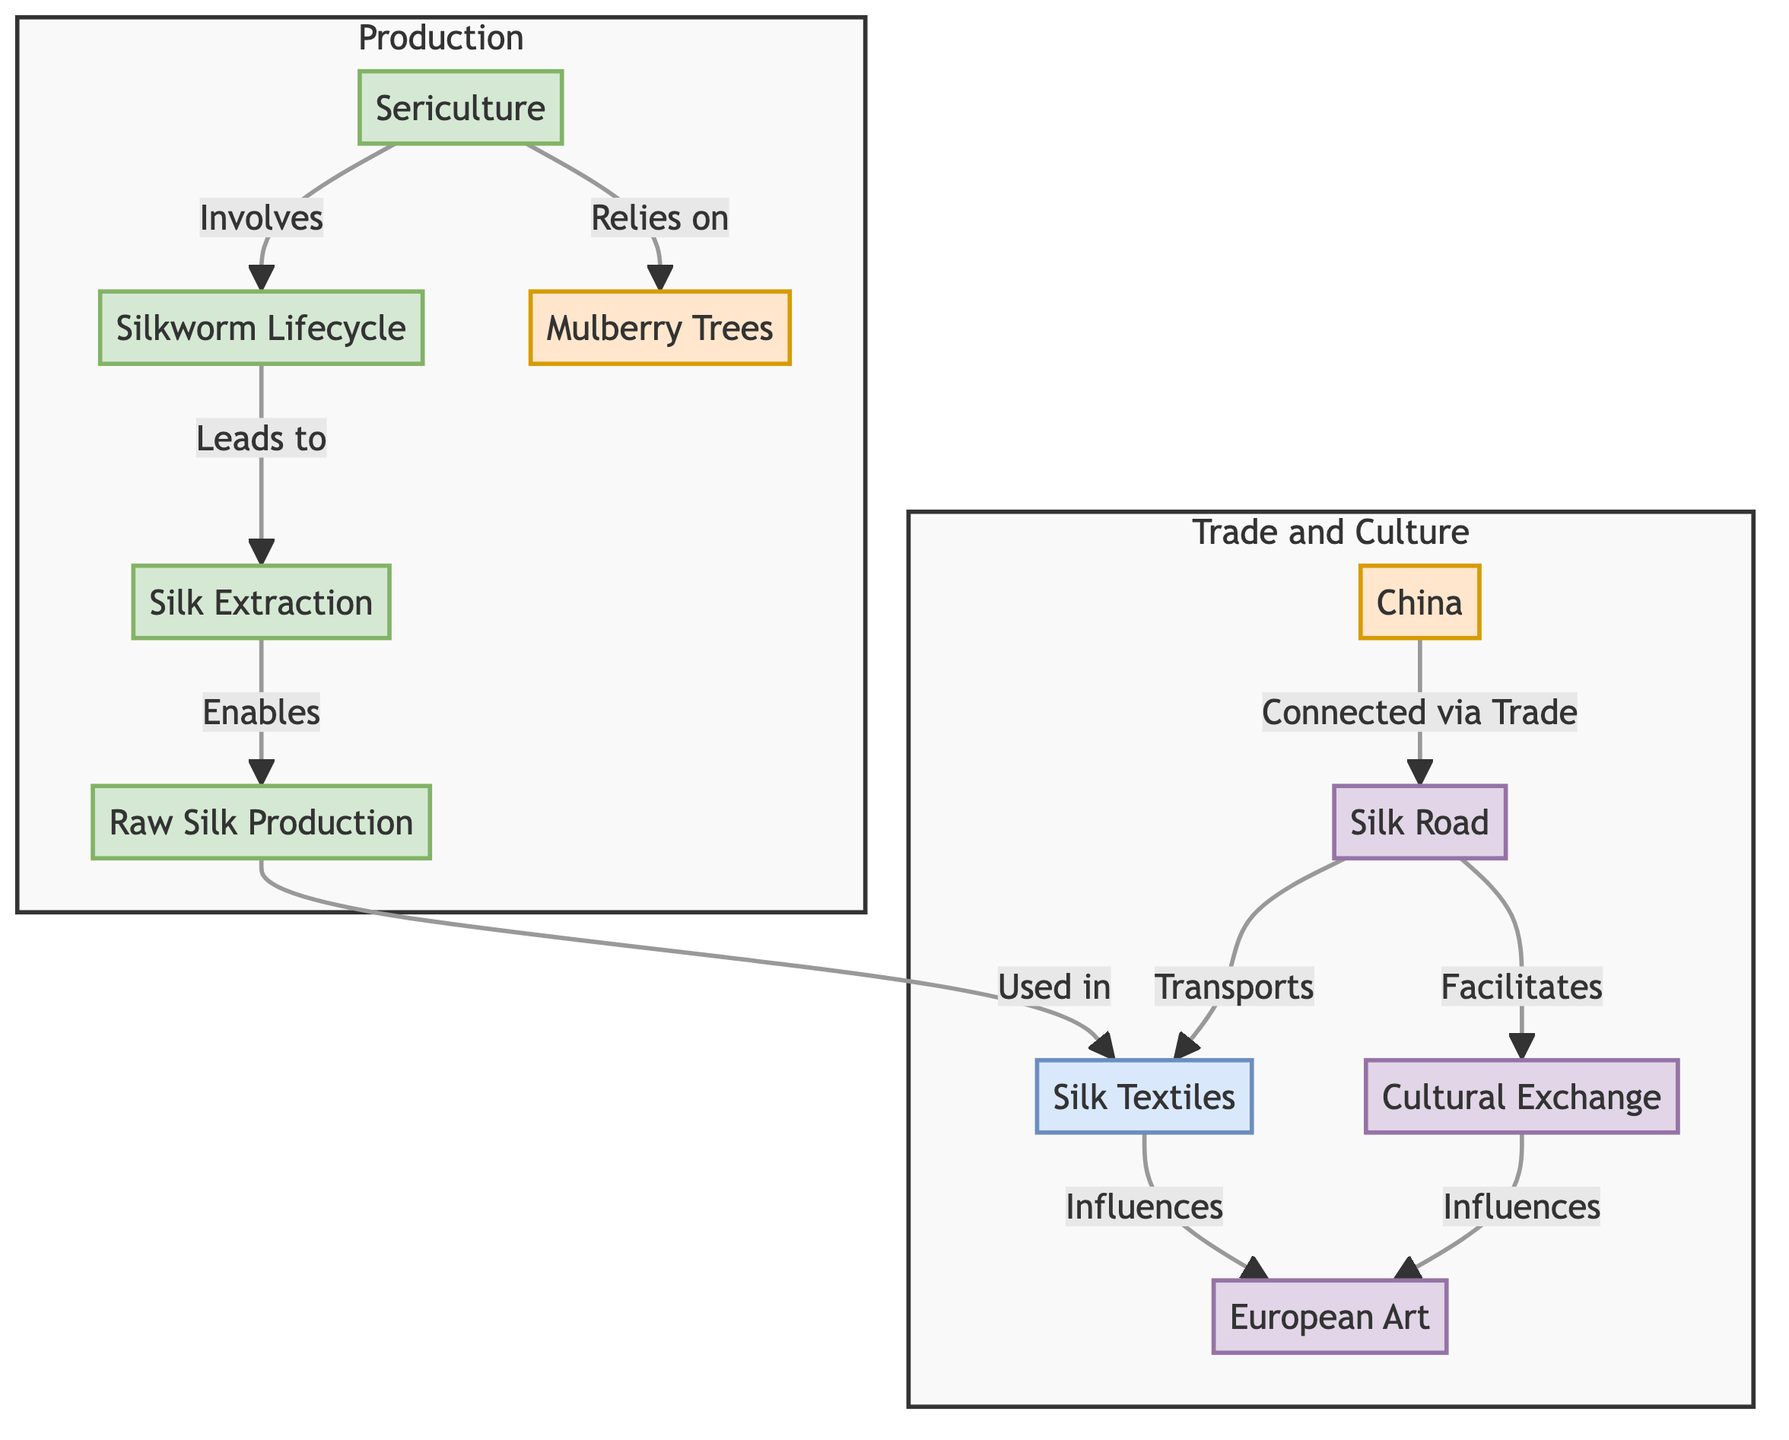What is the first process in the diagram? The diagram lists "Sericulture" as the first process node in the flowchart related to silk production.
Answer: Sericulture How many origin nodes are present in the diagram? The diagram has two origin nodes: "Mulberry Trees" and "China." Therefore, the total count is two.
Answer: 2 What does "Silkworm Lifecycle" lead to? According to the diagram, "Silkworm Lifecycle" directly leads to the next process, which is "Silk Extraction."
Answer: Silk Extraction Which product is produced from "Raw Silk Production"? The diagram specifies that "Raw Silk Production" is used in creating "Silk Textiles."
Answer: Silk Textiles How does "Cultural Exchange" relate to "Silk Road"? The diagram indicates that "Silk Road" facilitates "Cultural Exchange," meaning both are directly connected with a directional relationship.
Answer: Facilitates What node influences "European Art"? The diagram shows that "Silk Textiles," which are produced from the processes related to sericulture, influence "European Art."
Answer: Silk Textiles How many total nodes are present in the diagram, including all subgraphs? Counting all distinct nodes in both the Production and Trade and Culture subgraphs, we find ten nodes in total.
Answer: 10 What process directly follows "Silk Extraction"? The diagram clearly indicates that the next process following "Silk Extraction" is "Raw Silk Production."
Answer: Raw Silk Production What is the relationship between "China" and "Silk Road"? The diagram indicates that "China" is connected to "Silk Road" via trade, indicating a direct trade link between the two.
Answer: Connected via Trade 